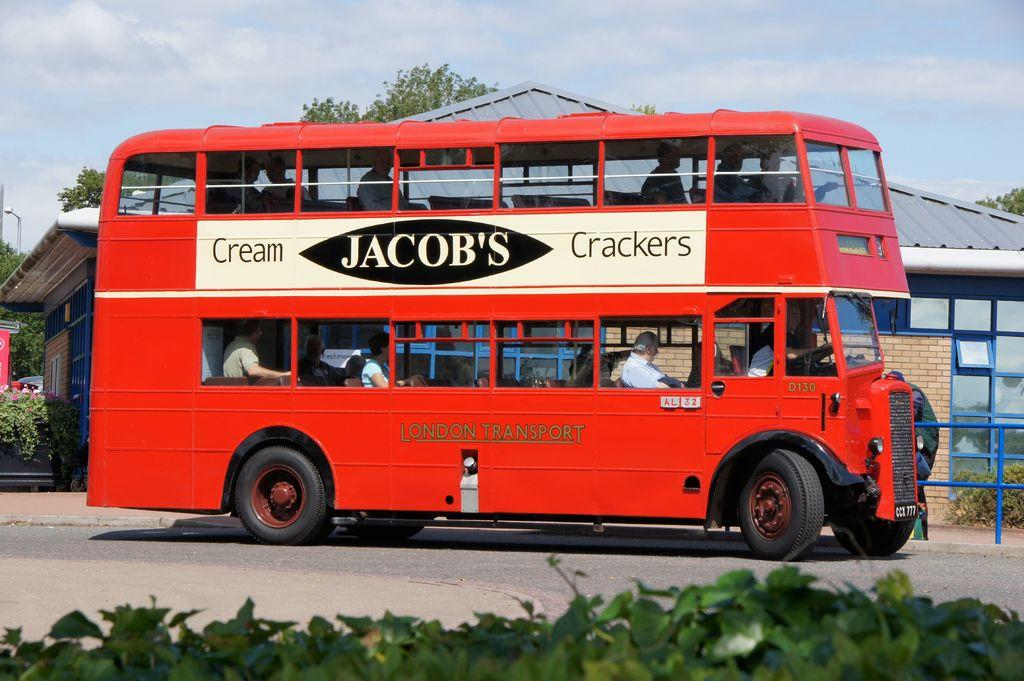What type of vegetation is at the bottom of the image? There are plants at the bottom of the image. What mode of transportation can be seen in the middle of the image? There is a bus in the middle of the image. What structures are visible in the background of the image? There are houses and trees in the background of the image. What is visible at the top of the image? The sky is visible at the top of the image. What type of frame is holding the plants in the image? There is no frame holding the plants in the image; they are not contained within a frame. What type of air is present in the image? The image does not depict a specific type of air; it simply shows the sky, which is a general representation of the Earth's atmosphere. 